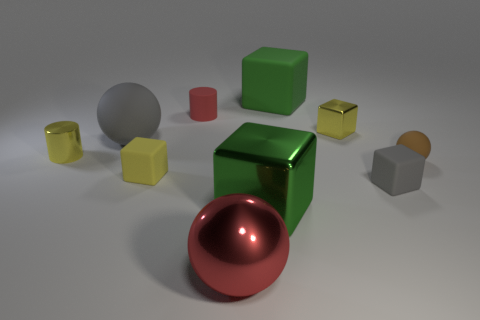Subtract all gray cubes. How many cubes are left? 4 Subtract all tiny metal blocks. How many blocks are left? 4 Subtract all brown blocks. Subtract all gray spheres. How many blocks are left? 5 Subtract all spheres. How many objects are left? 7 Add 4 big green objects. How many big green objects are left? 6 Add 4 big matte spheres. How many big matte spheres exist? 5 Subtract 1 brown balls. How many objects are left? 9 Subtract all gray blocks. Subtract all big matte things. How many objects are left? 7 